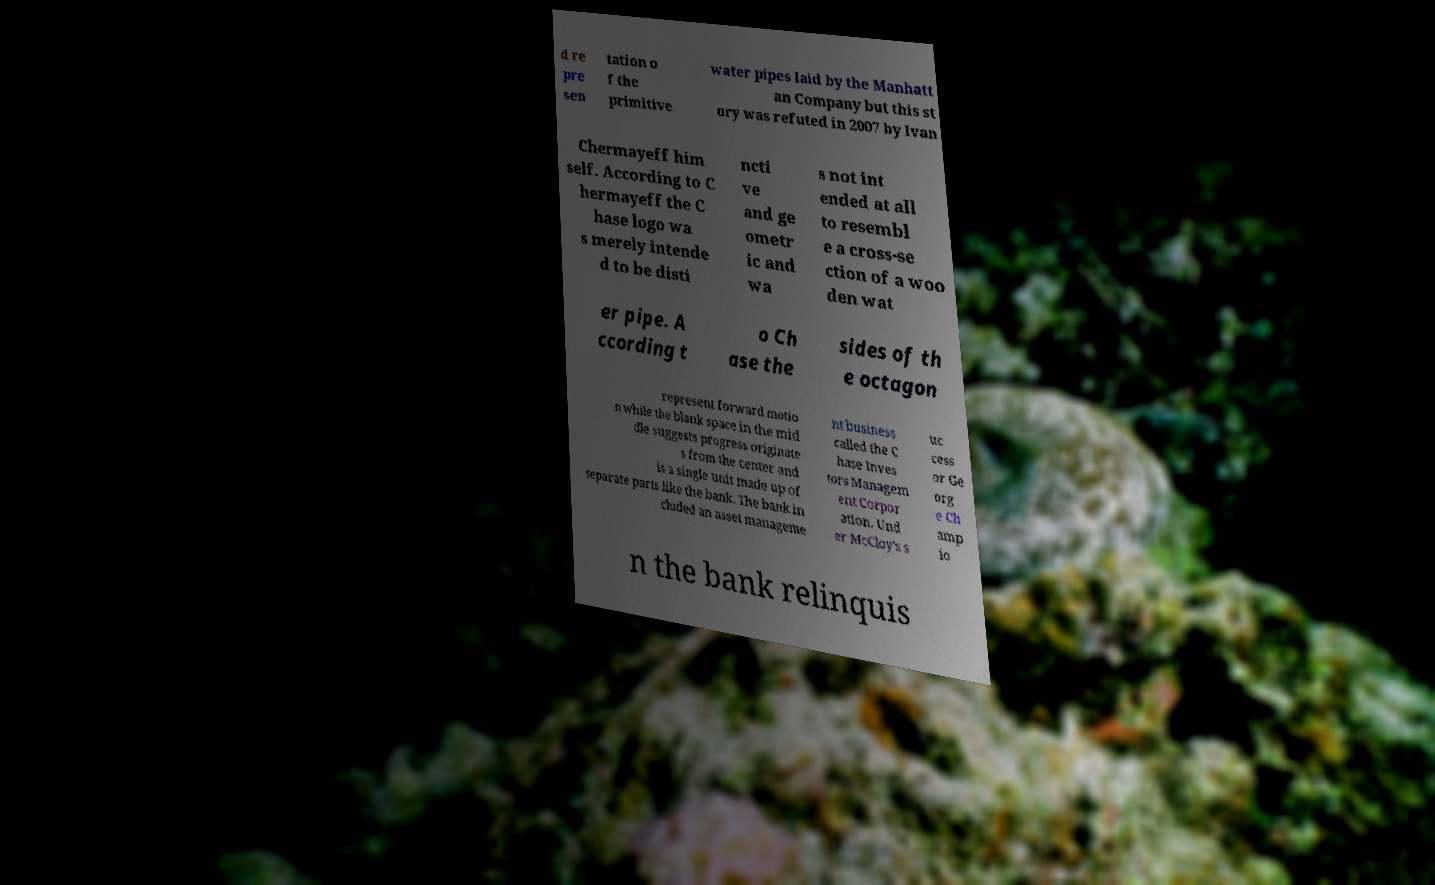Please identify and transcribe the text found in this image. d re pre sen tation o f the primitive water pipes laid by the Manhatt an Company but this st ory was refuted in 2007 by Ivan Chermayeff him self. According to C hermayeff the C hase logo wa s merely intende d to be disti ncti ve and ge ometr ic and wa s not int ended at all to resembl e a cross-se ction of a woo den wat er pipe. A ccording t o Ch ase the sides of th e octagon represent forward motio n while the blank space in the mid dle suggests progress originate s from the center and is a single unit made up of separate parts like the bank. The bank in cluded an asset manageme nt business called the C hase Inves tors Managem ent Corpor ation. Und er McCloy's s uc cess or Ge org e Ch amp io n the bank relinquis 